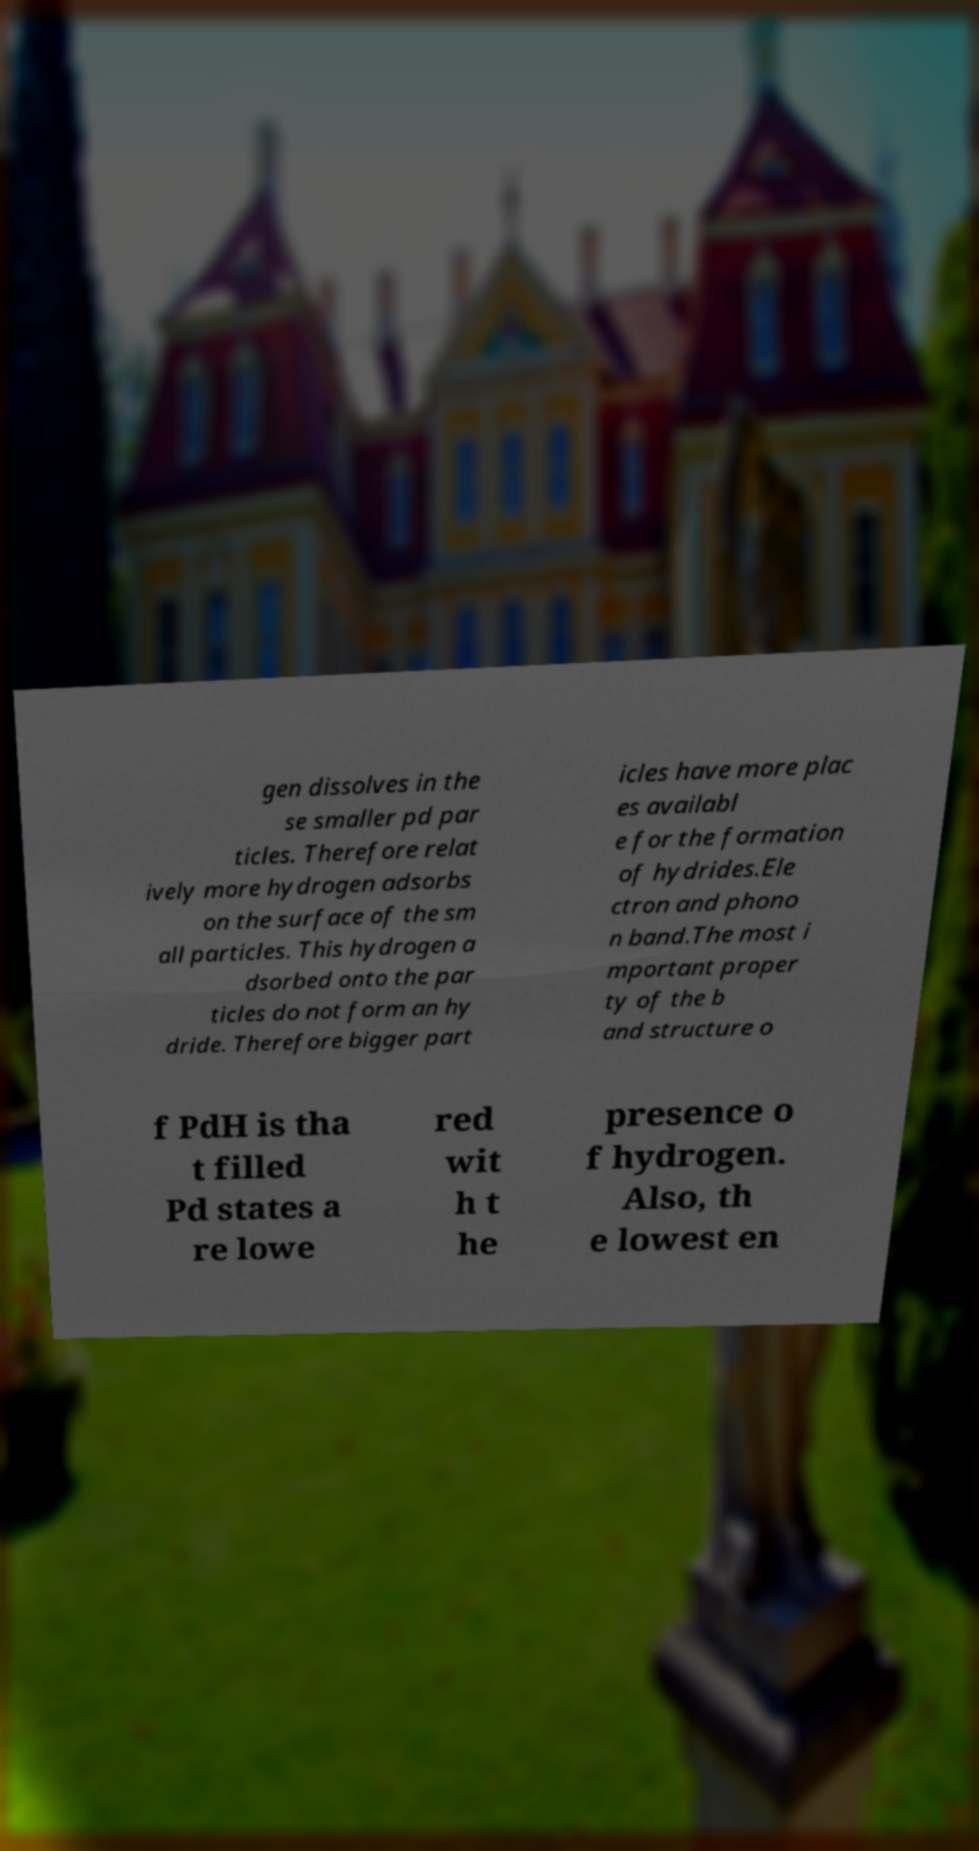Please identify and transcribe the text found in this image. gen dissolves in the se smaller pd par ticles. Therefore relat ively more hydrogen adsorbs on the surface of the sm all particles. This hydrogen a dsorbed onto the par ticles do not form an hy dride. Therefore bigger part icles have more plac es availabl e for the formation of hydrides.Ele ctron and phono n band.The most i mportant proper ty of the b and structure o f PdH is tha t filled Pd states a re lowe red wit h t he presence o f hydrogen. Also, th e lowest en 